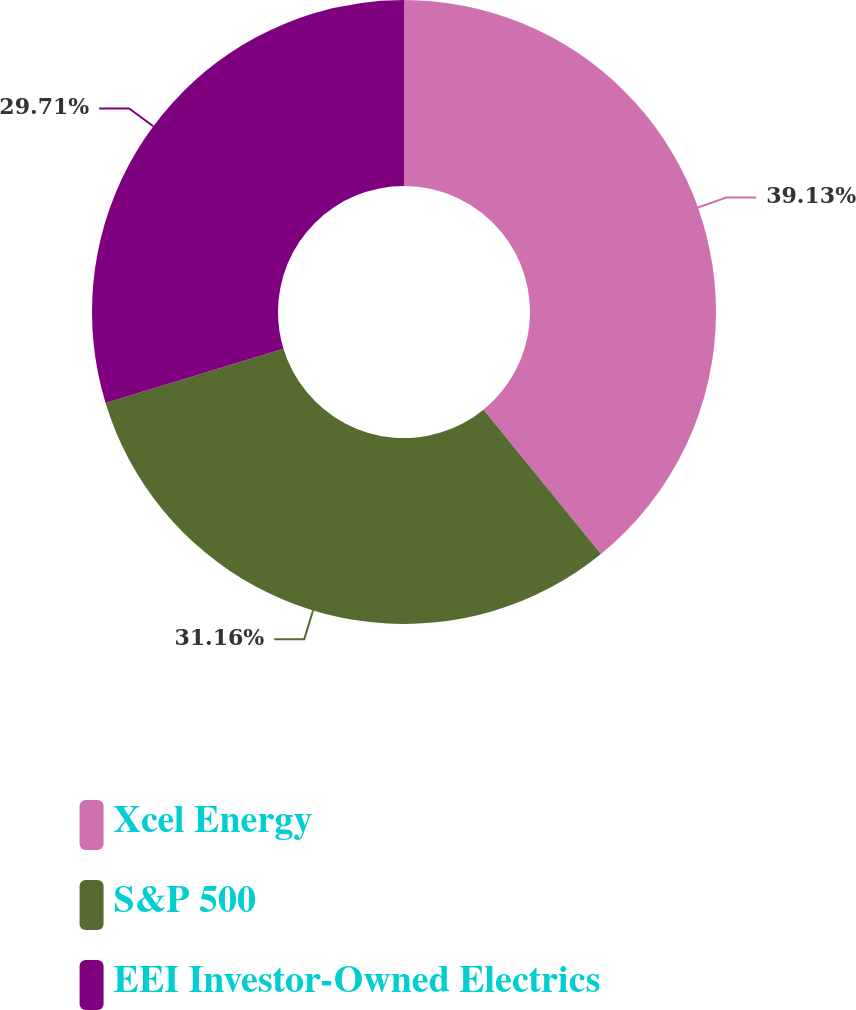<chart> <loc_0><loc_0><loc_500><loc_500><pie_chart><fcel>Xcel Energy<fcel>S&P 500<fcel>EEI Investor-Owned Electrics<nl><fcel>39.13%<fcel>31.16%<fcel>29.71%<nl></chart> 